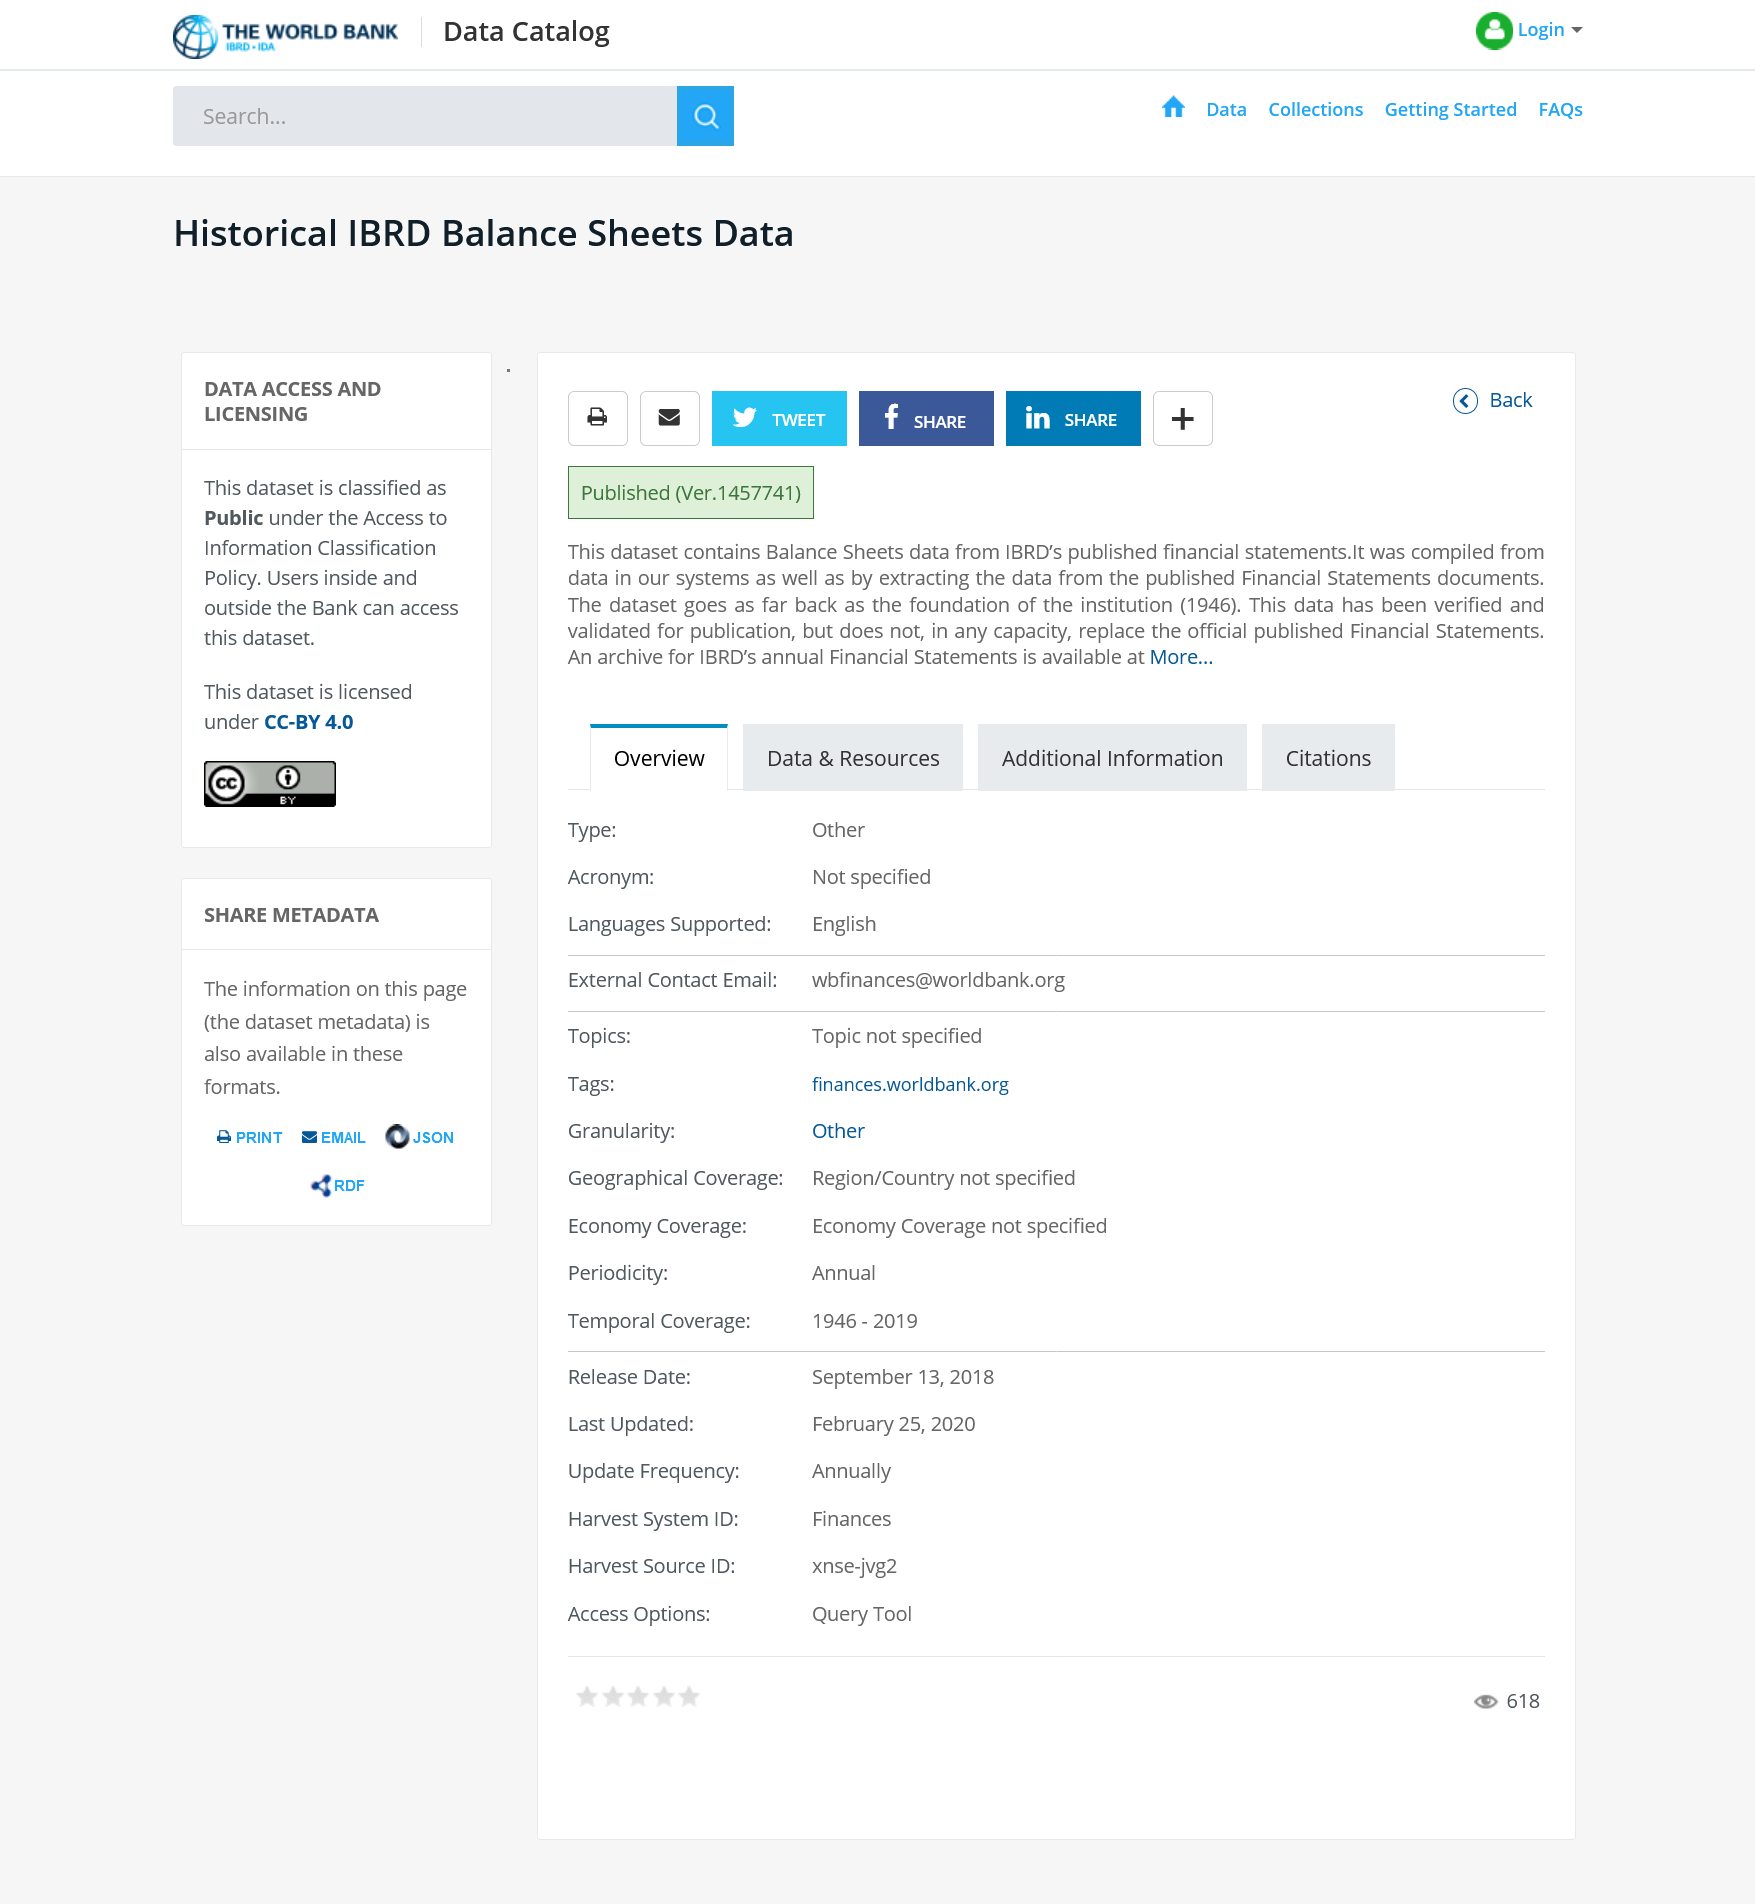Highlight a few significant elements in this photo. The dataset goes back as far as the founding of the institution in 1946. This dataset is accessible to both bank employees and external users. 